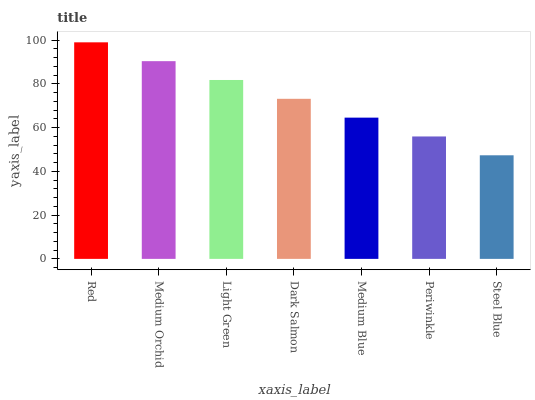Is Steel Blue the minimum?
Answer yes or no. Yes. Is Red the maximum?
Answer yes or no. Yes. Is Medium Orchid the minimum?
Answer yes or no. No. Is Medium Orchid the maximum?
Answer yes or no. No. Is Red greater than Medium Orchid?
Answer yes or no. Yes. Is Medium Orchid less than Red?
Answer yes or no. Yes. Is Medium Orchid greater than Red?
Answer yes or no. No. Is Red less than Medium Orchid?
Answer yes or no. No. Is Dark Salmon the high median?
Answer yes or no. Yes. Is Dark Salmon the low median?
Answer yes or no. Yes. Is Light Green the high median?
Answer yes or no. No. Is Light Green the low median?
Answer yes or no. No. 